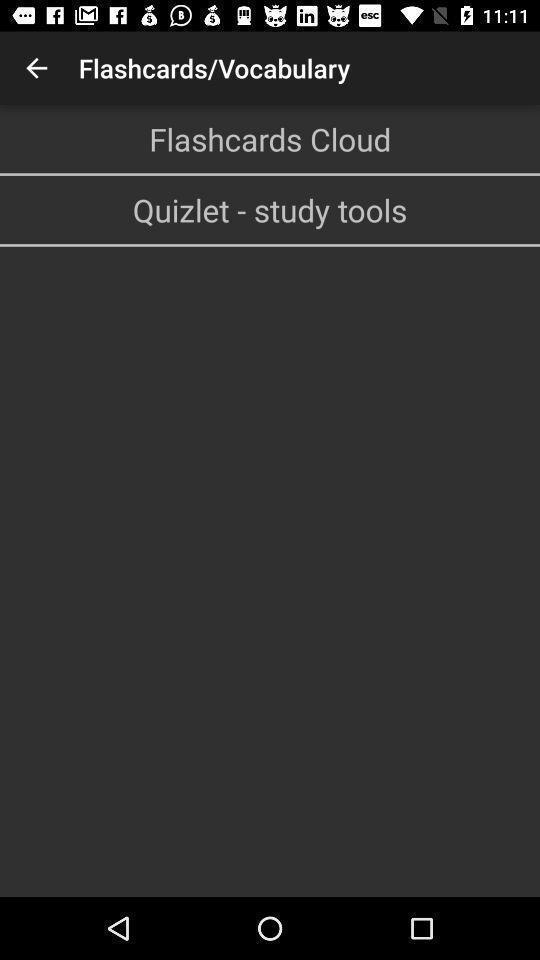Describe the content in this image. Screen displaying multiple options in a translator application. 